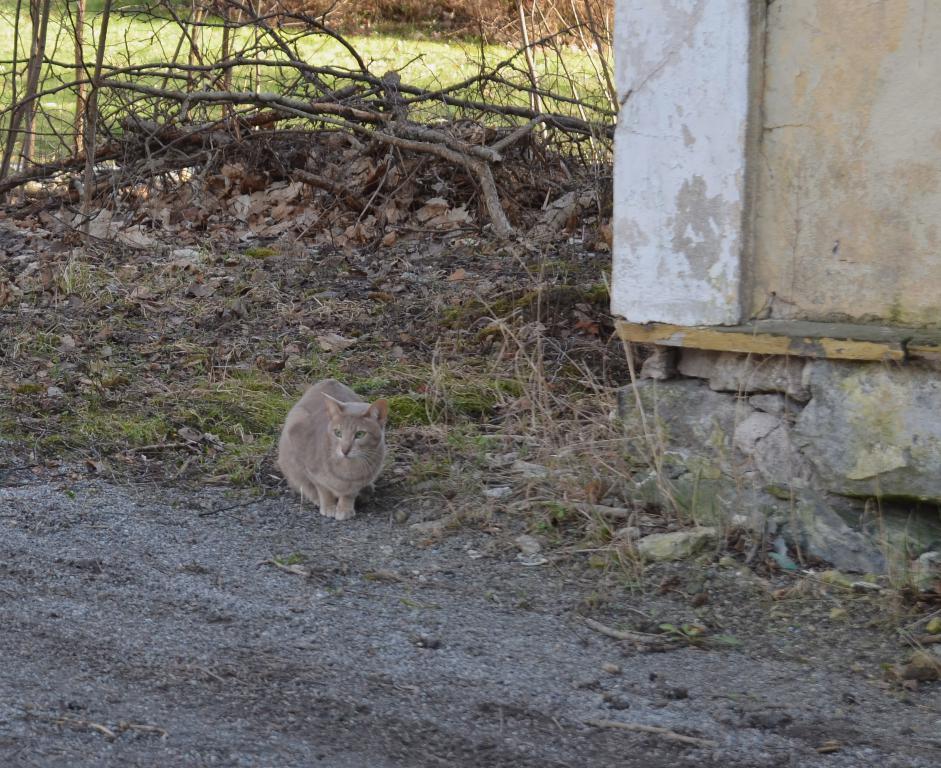How would you summarize this image in a sentence or two? In this picture we can see brown cat sitting on the ground. Behind there are some dry leaves and tree branches. On the left side there is a white wall and some stones. 